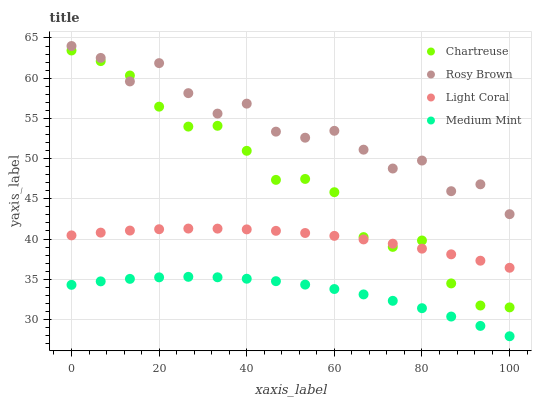Does Medium Mint have the minimum area under the curve?
Answer yes or no. Yes. Does Rosy Brown have the maximum area under the curve?
Answer yes or no. Yes. Does Chartreuse have the minimum area under the curve?
Answer yes or no. No. Does Chartreuse have the maximum area under the curve?
Answer yes or no. No. Is Light Coral the smoothest?
Answer yes or no. Yes. Is Rosy Brown the roughest?
Answer yes or no. Yes. Is Medium Mint the smoothest?
Answer yes or no. No. Is Medium Mint the roughest?
Answer yes or no. No. Does Medium Mint have the lowest value?
Answer yes or no. Yes. Does Chartreuse have the lowest value?
Answer yes or no. No. Does Rosy Brown have the highest value?
Answer yes or no. Yes. Does Chartreuse have the highest value?
Answer yes or no. No. Is Medium Mint less than Rosy Brown?
Answer yes or no. Yes. Is Rosy Brown greater than Medium Mint?
Answer yes or no. Yes. Does Rosy Brown intersect Chartreuse?
Answer yes or no. Yes. Is Rosy Brown less than Chartreuse?
Answer yes or no. No. Is Rosy Brown greater than Chartreuse?
Answer yes or no. No. Does Medium Mint intersect Rosy Brown?
Answer yes or no. No. 